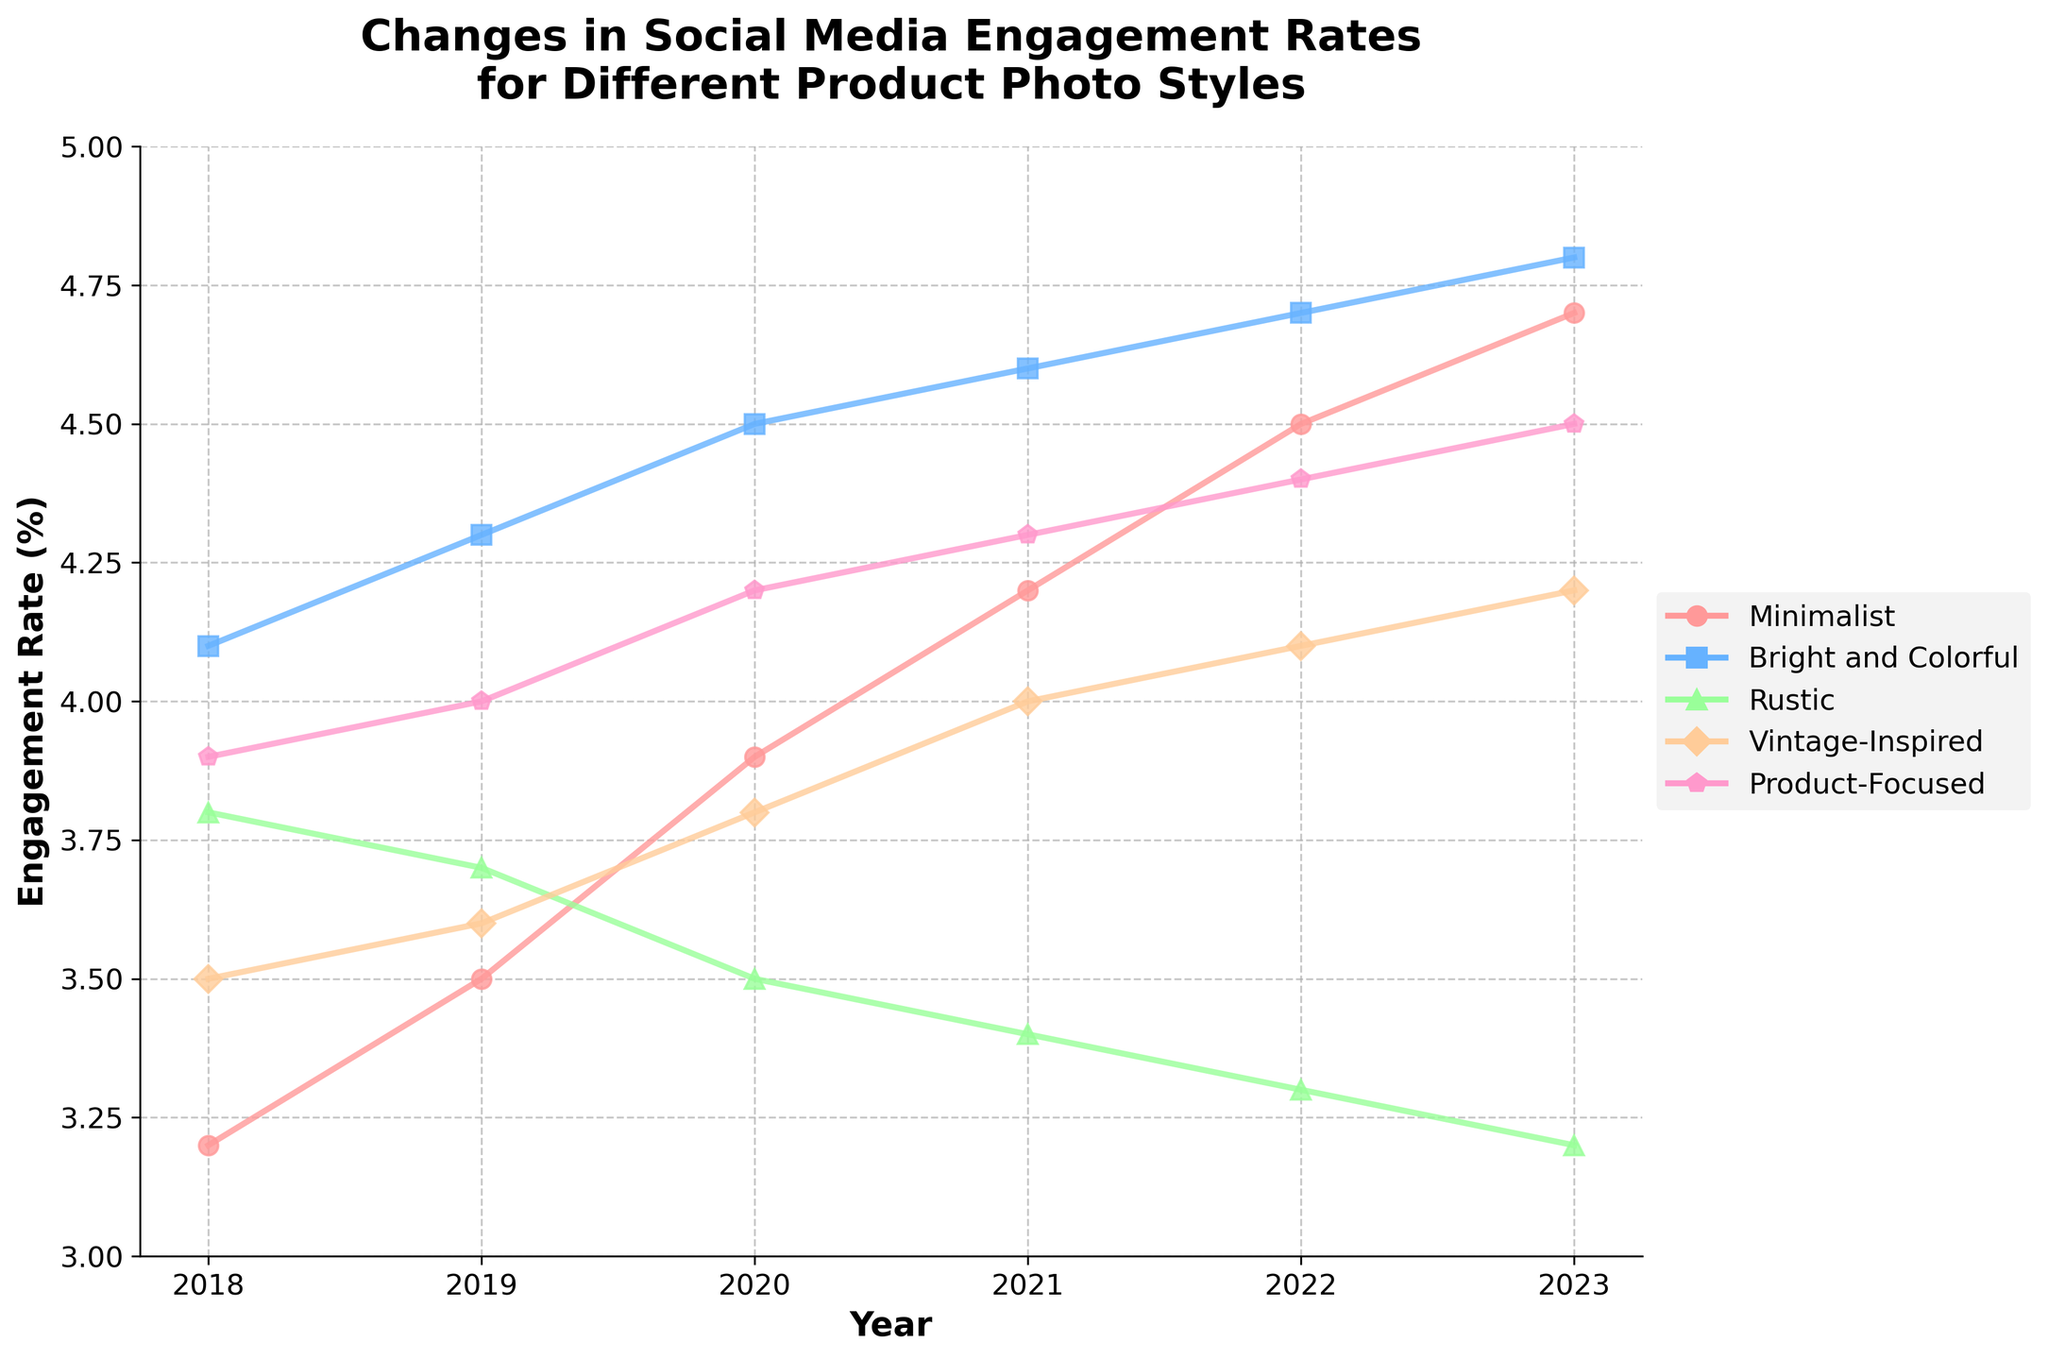How did the social media engagement rate for Minimalist style change from 2018 to 2023? Start by identifying the engagement rates for Minimalist in 2018 and 2023. The rate in 2018 is 3.2% and in 2023 it is 4.7%. Calculate the difference: 4.7% - 3.2% = 1.5%.
Answer: Increased by 1.5% Which product photo style had the highest engagement rate in 2023? Examine the engagement rates for all styles in 2023: Minimalist (4.7%), Bright and Colorful (4.8%), Rustic (3.2%), Vintage-Inspired (4.2%), Product-Focused (4.5%). The highest rate is 4.8% for Bright and Colorful.
Answer: Bright and Colorful What was the trend for Rustic style from 2018 to 2023? Look at the engagement rates for Rustic each year: 2018 (3.8%), 2019 (3.7%), 2020 (3.5%), 2021 (3.4%), 2022 (3.3%), 2023 (3.2%). The trend is a consistent decrease each year.
Answer: Decreasing Compare the engagement rates between Vintage-Inspired and Product-Focused styles in 2021. Which was higher? Check the rates for both styles in 2021: Vintage-Inspired (4.0%) and Product-Focused (4.3%). Product-Focused is higher.
Answer: Product-Focused What is the average engagement rate for Bright and Colorful style from 2018 to 2023? Find the rates: 2018 (4.1%), 2019 (4.3%), 2020 (4.5%), 2021 (4.6%), 2022 (4.7%), 2023 (4.8%). Sum them: 4.1 + 4.3 + 4.5 + 4.6 + 4.7 + 4.8 = 26. Sum of six values divided by 6: 26 / 6 ≈ 4.33.
Answer: 4.33 By how much did the engagement rate for Product-Focused improve from 2019 to 2022? The rate for Product-Focused in 2019 is 4.0%, and in 2022 it is 4.4%. Calculate the difference: 4.4% - 4.0% = 0.4%.
Answer: Increased by 0.4% Which styles had an engagement rate lower than 4.0% in 2023? Check the rates for all styles in 2023: Minimalist (4.7%), Bright and Colorful (4.8%), Rustic (3.2%), Vintage-Inspired (4.2%), Product-Focused (4.5%). Only Rustic (3.2%) is lower than 4.0%.
Answer: Rustic What is the overall trend for Vintage-Inspired style from 2018 to 2023? Review the rates: 2018 (3.5%), 2019 (3.6%), 2020 (3.8%), 2021 (4.0%), 2022 (4.1%), 2023 (4.2%). The trend shows a steady increase each year.
Answer: Increasing Which year did Bright and Colorful style overtake all other styles in engagement rate? Compare Bright and Colorful each year with others. In 2023, Bright and Colorful (4.8%) is higher than Minimalist (4.7%), Rustic (3.2%), Vintage-Inspired (4.2%), Product-Focused (4.5%).
Answer: 2023 